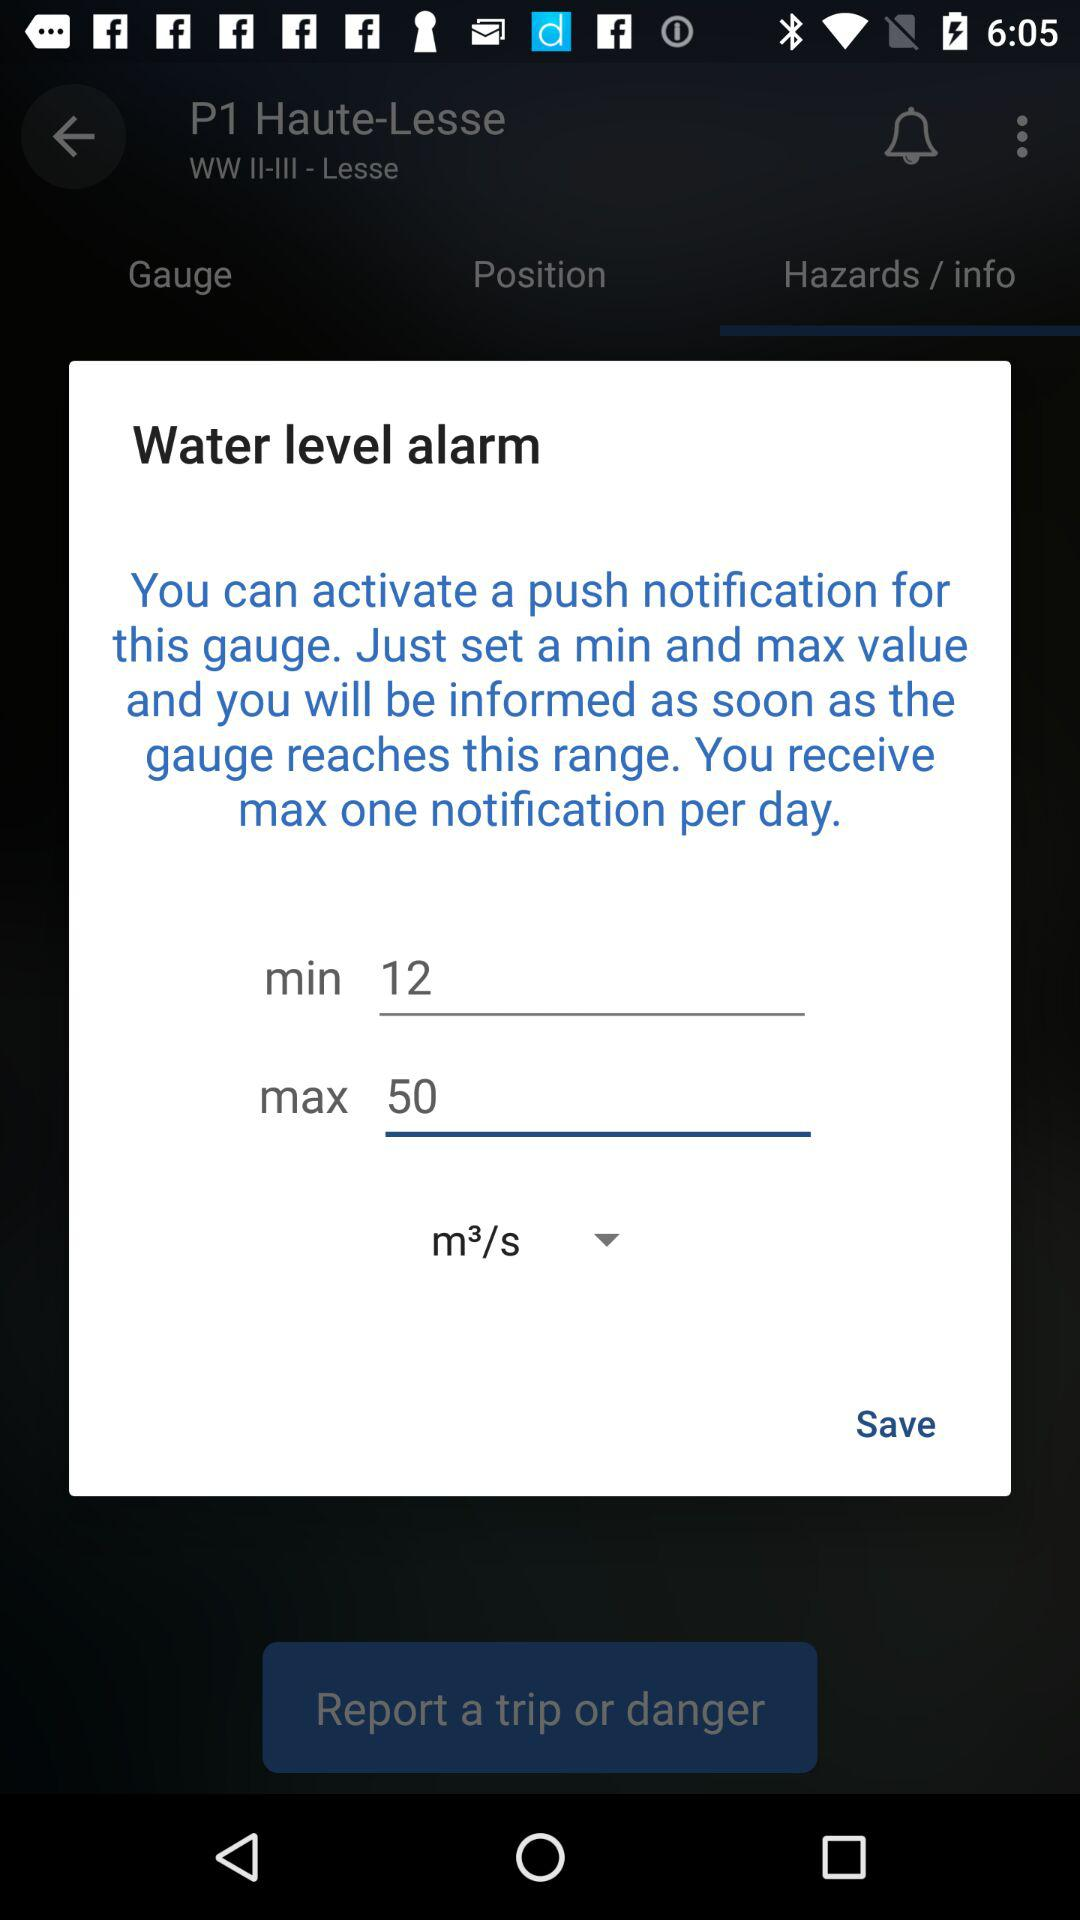What is the sum of the min and max values?
Answer the question using a single word or phrase. 62 